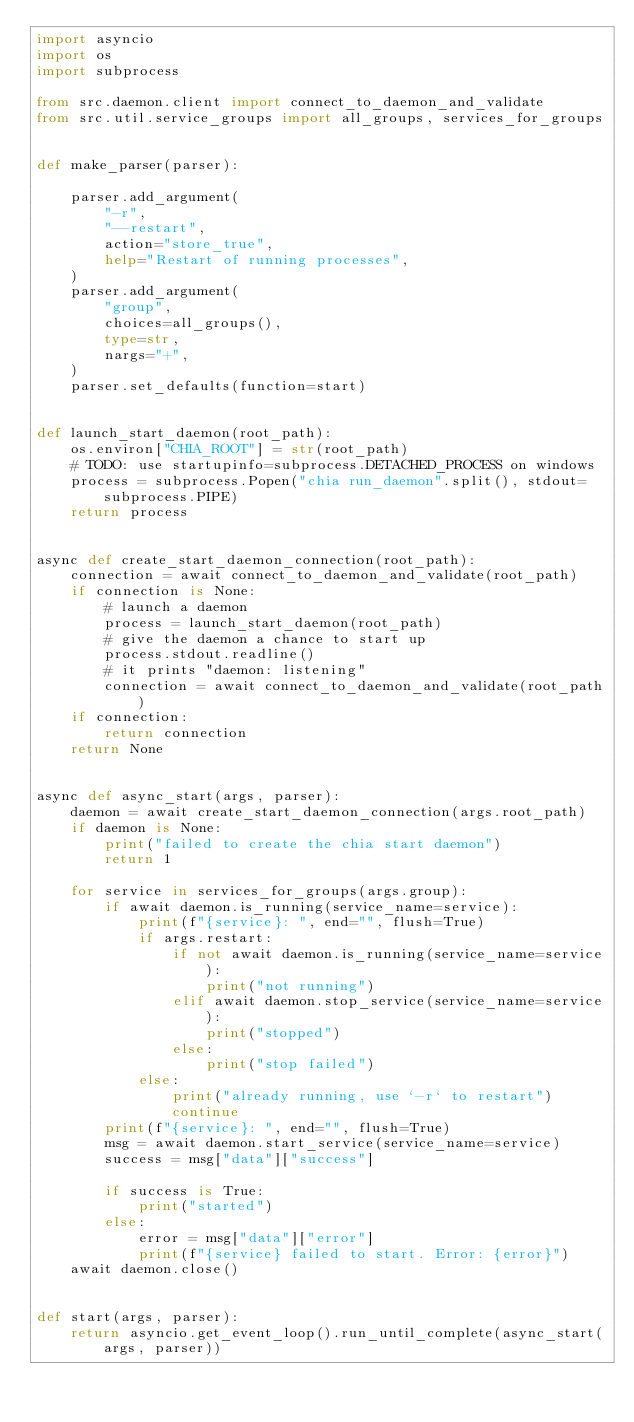Convert code to text. <code><loc_0><loc_0><loc_500><loc_500><_Python_>import asyncio
import os
import subprocess

from src.daemon.client import connect_to_daemon_and_validate
from src.util.service_groups import all_groups, services_for_groups


def make_parser(parser):

    parser.add_argument(
        "-r",
        "--restart",
        action="store_true",
        help="Restart of running processes",
    )
    parser.add_argument(
        "group",
        choices=all_groups(),
        type=str,
        nargs="+",
    )
    parser.set_defaults(function=start)


def launch_start_daemon(root_path):
    os.environ["CHIA_ROOT"] = str(root_path)
    # TODO: use startupinfo=subprocess.DETACHED_PROCESS on windows
    process = subprocess.Popen("chia run_daemon".split(), stdout=subprocess.PIPE)
    return process


async def create_start_daemon_connection(root_path):
    connection = await connect_to_daemon_and_validate(root_path)
    if connection is None:
        # launch a daemon
        process = launch_start_daemon(root_path)
        # give the daemon a chance to start up
        process.stdout.readline()
        # it prints "daemon: listening"
        connection = await connect_to_daemon_and_validate(root_path)
    if connection:
        return connection
    return None


async def async_start(args, parser):
    daemon = await create_start_daemon_connection(args.root_path)
    if daemon is None:
        print("failed to create the chia start daemon")
        return 1

    for service in services_for_groups(args.group):
        if await daemon.is_running(service_name=service):
            print(f"{service}: ", end="", flush=True)
            if args.restart:
                if not await daemon.is_running(service_name=service):
                    print("not running")
                elif await daemon.stop_service(service_name=service):
                    print("stopped")
                else:
                    print("stop failed")
            else:
                print("already running, use `-r` to restart")
                continue
        print(f"{service}: ", end="", flush=True)
        msg = await daemon.start_service(service_name=service)
        success = msg["data"]["success"]

        if success is True:
            print("started")
        else:
            error = msg["data"]["error"]
            print(f"{service} failed to start. Error: {error}")
    await daemon.close()


def start(args, parser):
    return asyncio.get_event_loop().run_until_complete(async_start(args, parser))
</code> 